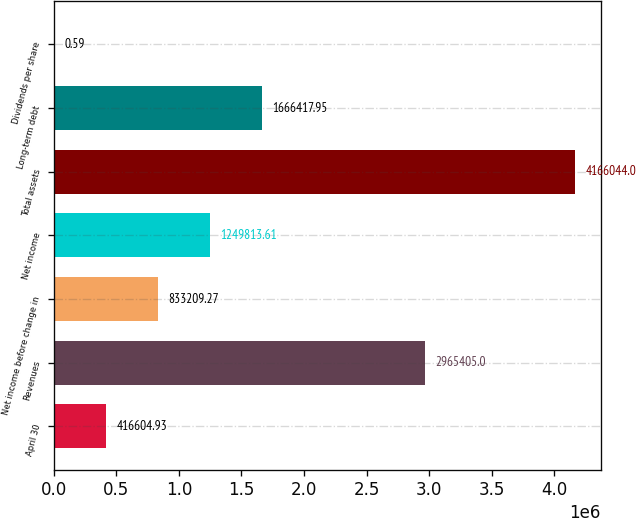<chart> <loc_0><loc_0><loc_500><loc_500><bar_chart><fcel>April 30<fcel>Revenues<fcel>Net income before change in<fcel>Net income<fcel>Total assets<fcel>Long-term debt<fcel>Dividends per share<nl><fcel>416605<fcel>2.9654e+06<fcel>833209<fcel>1.24981e+06<fcel>4.16604e+06<fcel>1.66642e+06<fcel>0.59<nl></chart> 